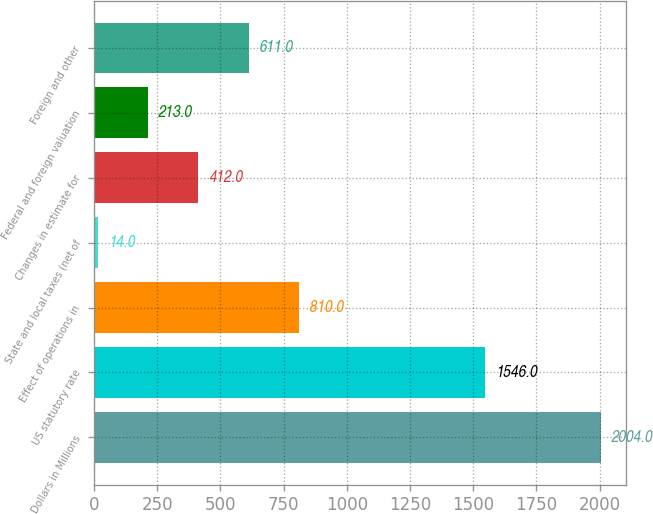Convert chart. <chart><loc_0><loc_0><loc_500><loc_500><bar_chart><fcel>Dollars in Millions<fcel>US statutory rate<fcel>Effect of operations in<fcel>State and local taxes (net of<fcel>Changes in estimate for<fcel>Federal and foreign valuation<fcel>Foreign and other<nl><fcel>2004<fcel>1546<fcel>810<fcel>14<fcel>412<fcel>213<fcel>611<nl></chart> 